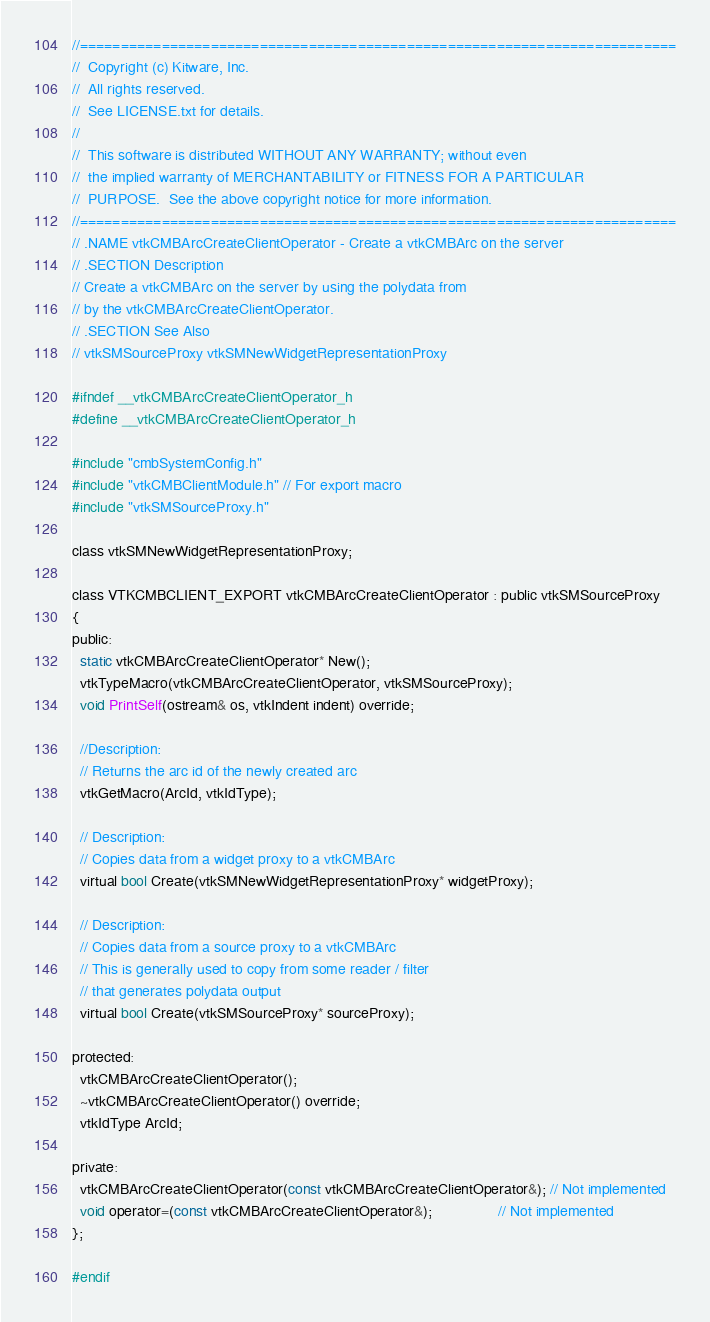Convert code to text. <code><loc_0><loc_0><loc_500><loc_500><_C_>//=========================================================================
//  Copyright (c) Kitware, Inc.
//  All rights reserved.
//  See LICENSE.txt for details.
//
//  This software is distributed WITHOUT ANY WARRANTY; without even
//  the implied warranty of MERCHANTABILITY or FITNESS FOR A PARTICULAR
//  PURPOSE.  See the above copyright notice for more information.
//=========================================================================
// .NAME vtkCMBArcCreateClientOperator - Create a vtkCMBArc on the server
// .SECTION Description
// Create a vtkCMBArc on the server by using the polydata from
// by the vtkCMBArcCreateClientOperator.
// .SECTION See Also
// vtkSMSourceProxy vtkSMNewWidgetRepresentationProxy

#ifndef __vtkCMBArcCreateClientOperator_h
#define __vtkCMBArcCreateClientOperator_h

#include "cmbSystemConfig.h"
#include "vtkCMBClientModule.h" // For export macro
#include "vtkSMSourceProxy.h"

class vtkSMNewWidgetRepresentationProxy;

class VTKCMBCLIENT_EXPORT vtkCMBArcCreateClientOperator : public vtkSMSourceProxy
{
public:
  static vtkCMBArcCreateClientOperator* New();
  vtkTypeMacro(vtkCMBArcCreateClientOperator, vtkSMSourceProxy);
  void PrintSelf(ostream& os, vtkIndent indent) override;

  //Description:
  // Returns the arc id of the newly created arc
  vtkGetMacro(ArcId, vtkIdType);

  // Description:
  // Copies data from a widget proxy to a vtkCMBArc
  virtual bool Create(vtkSMNewWidgetRepresentationProxy* widgetProxy);

  // Description:
  // Copies data from a source proxy to a vtkCMBArc
  // This is generally used to copy from some reader / filter
  // that generates polydata output
  virtual bool Create(vtkSMSourceProxy* sourceProxy);

protected:
  vtkCMBArcCreateClientOperator();
  ~vtkCMBArcCreateClientOperator() override;
  vtkIdType ArcId;

private:
  vtkCMBArcCreateClientOperator(const vtkCMBArcCreateClientOperator&); // Not implemented
  void operator=(const vtkCMBArcCreateClientOperator&);                // Not implemented
};

#endif
</code> 